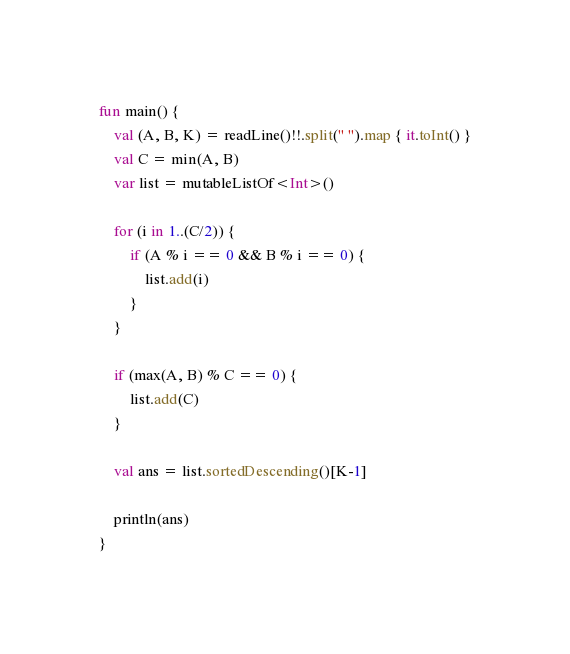<code> <loc_0><loc_0><loc_500><loc_500><_Kotlin_>fun main() {
    val (A, B, K) = readLine()!!.split(" ").map { it.toInt() }
    val C = min(A, B)
    var list = mutableListOf<Int>()

    for (i in 1..(C/2)) {
        if (A % i == 0 && B % i == 0) {
            list.add(i)
        }
    }

    if (max(A, B) % C == 0) {
        list.add(C)
    }

    val ans = list.sortedDescending()[K-1]

    println(ans)
}</code> 